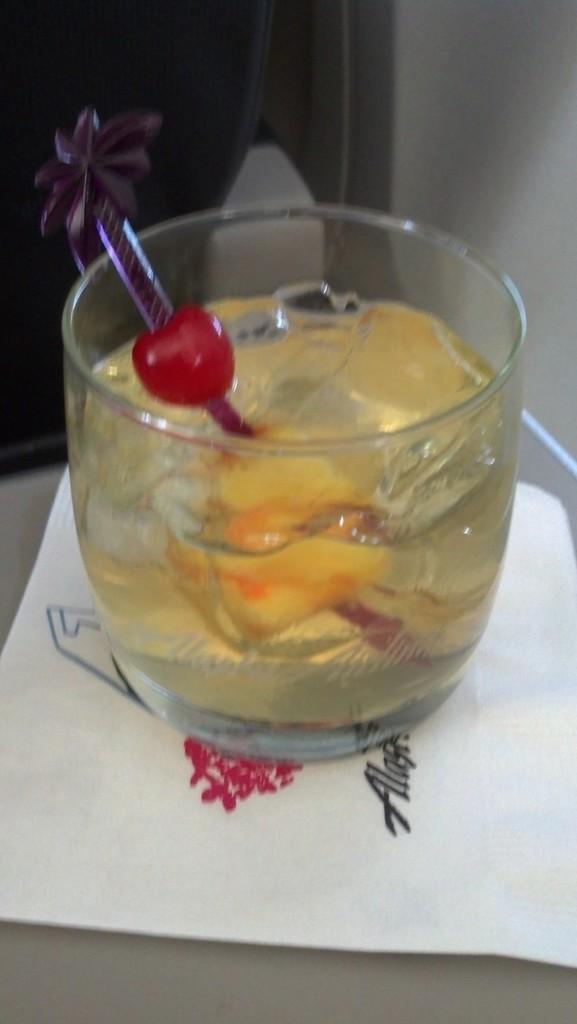Describe this image in one or two sentences. In this image there is a table truncated towards the bottom of the image, there is a paper on the table, there is text on the paper, there is a glass on the paper, there is the drink in the glass, there is an object in the glass, there is a wall truncated truncated towards the right of the image, there is an object truncated towards the left of the image. 